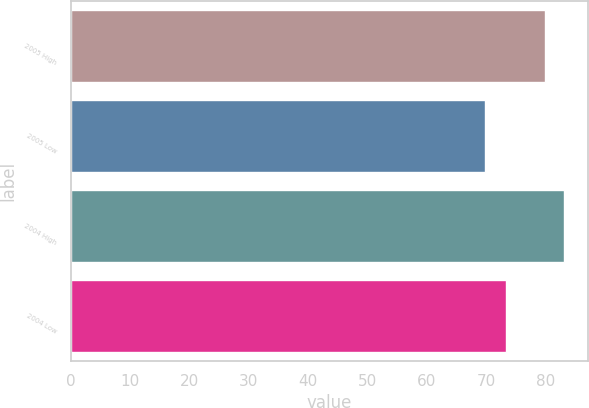Convert chart. <chart><loc_0><loc_0><loc_500><loc_500><bar_chart><fcel>2005 High<fcel>2005 Low<fcel>2004 High<fcel>2004 Low<nl><fcel>79.84<fcel>69.71<fcel>83.03<fcel>73.31<nl></chart> 